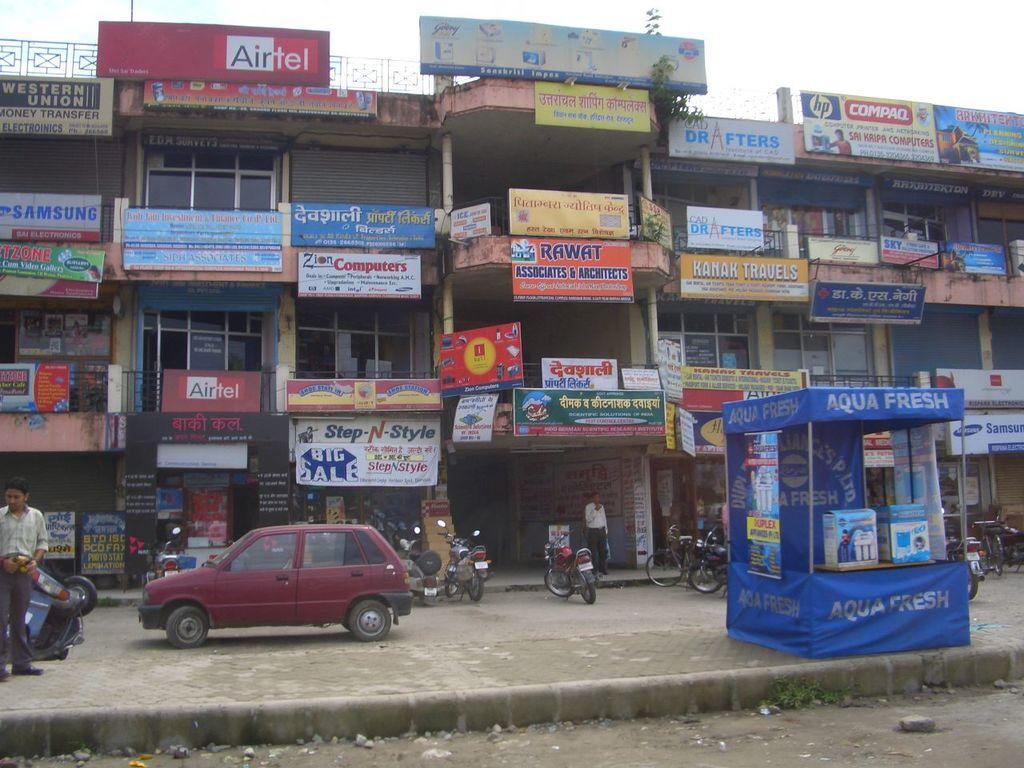In one or two sentences, can you explain what this image depicts? In this image I can see few vehicles,different boards,railing,building and small plant. The sky is in white color. In front I can see a blue color tint and two boxes on the table. The boards are in different color. 